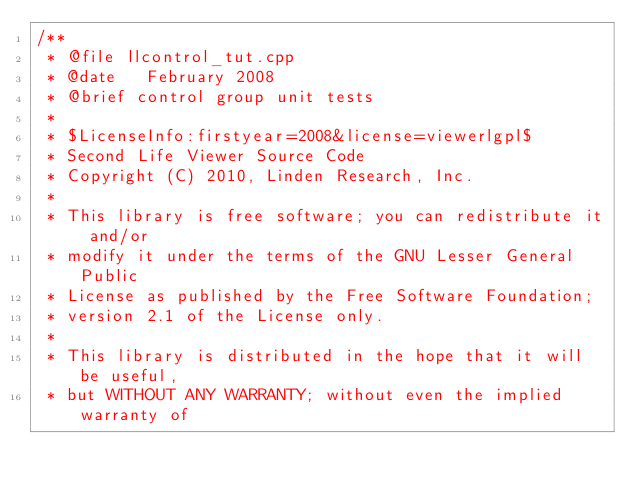<code> <loc_0><loc_0><loc_500><loc_500><_C++_>/** 
 * @file llcontrol_tut.cpp
 * @date   February 2008
 * @brief control group unit tests
 *
 * $LicenseInfo:firstyear=2008&license=viewerlgpl$
 * Second Life Viewer Source Code
 * Copyright (C) 2010, Linden Research, Inc.
 * 
 * This library is free software; you can redistribute it and/or
 * modify it under the terms of the GNU Lesser General Public
 * License as published by the Free Software Foundation;
 * version 2.1 of the License only.
 * 
 * This library is distributed in the hope that it will be useful,
 * but WITHOUT ANY WARRANTY; without even the implied warranty of</code> 